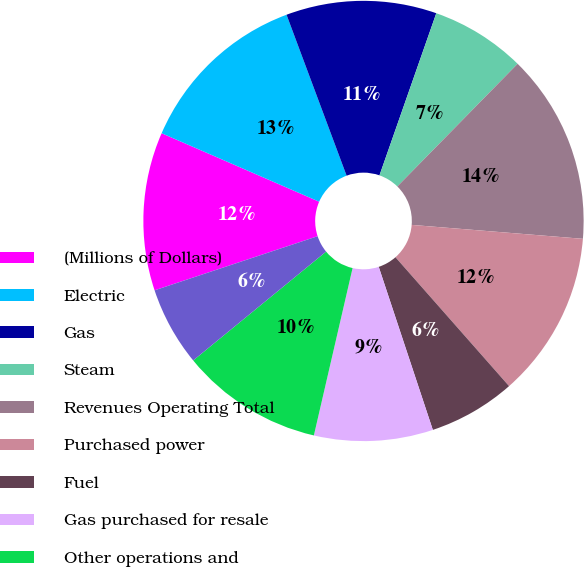Convert chart to OTSL. <chart><loc_0><loc_0><loc_500><loc_500><pie_chart><fcel>(Millions of Dollars)<fcel>Electric<fcel>Gas<fcel>Steam<fcel>Revenues Operating Total<fcel>Purchased power<fcel>Fuel<fcel>Gas purchased for resale<fcel>Other operations and<fcel>Depreciation and amortization<nl><fcel>11.63%<fcel>12.79%<fcel>11.05%<fcel>6.98%<fcel>13.95%<fcel>12.21%<fcel>6.4%<fcel>8.72%<fcel>10.46%<fcel>5.82%<nl></chart> 